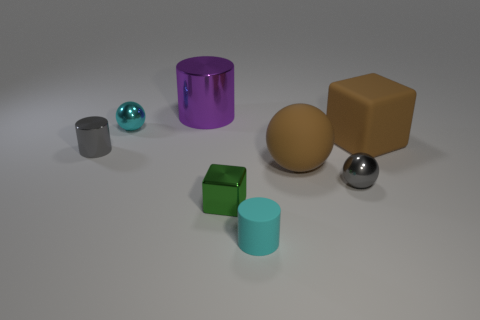Is the shape of the gray metallic object left of the big purple cylinder the same as the metal object that is to the right of the big brown matte ball?
Make the answer very short. No. There is a small object that is right of the large brown rubber object that is on the left side of the big matte block; what is its shape?
Your answer should be very brief. Sphere. There is a thing that is in front of the gray sphere and on the right side of the green thing; how big is it?
Your response must be concise. Small. There is a tiny cyan matte thing; is its shape the same as the small object on the right side of the large brown sphere?
Ensure brevity in your answer.  No. There is a brown matte object that is the same shape as the cyan metal thing; what size is it?
Make the answer very short. Large. There is a tiny shiny cylinder; does it have the same color as the metallic sphere to the right of the tiny green metallic object?
Make the answer very short. Yes. What number of other things are there of the same size as the green thing?
Ensure brevity in your answer.  4. What is the shape of the gray object to the left of the object that is behind the tiny metallic sphere behind the tiny gray shiny cylinder?
Provide a short and direct response. Cylinder. Is the size of the green block the same as the gray thing on the left side of the matte cylinder?
Your response must be concise. Yes. There is a large object that is both to the left of the gray shiny sphere and behind the small gray shiny cylinder; what is its color?
Provide a succinct answer. Purple. 